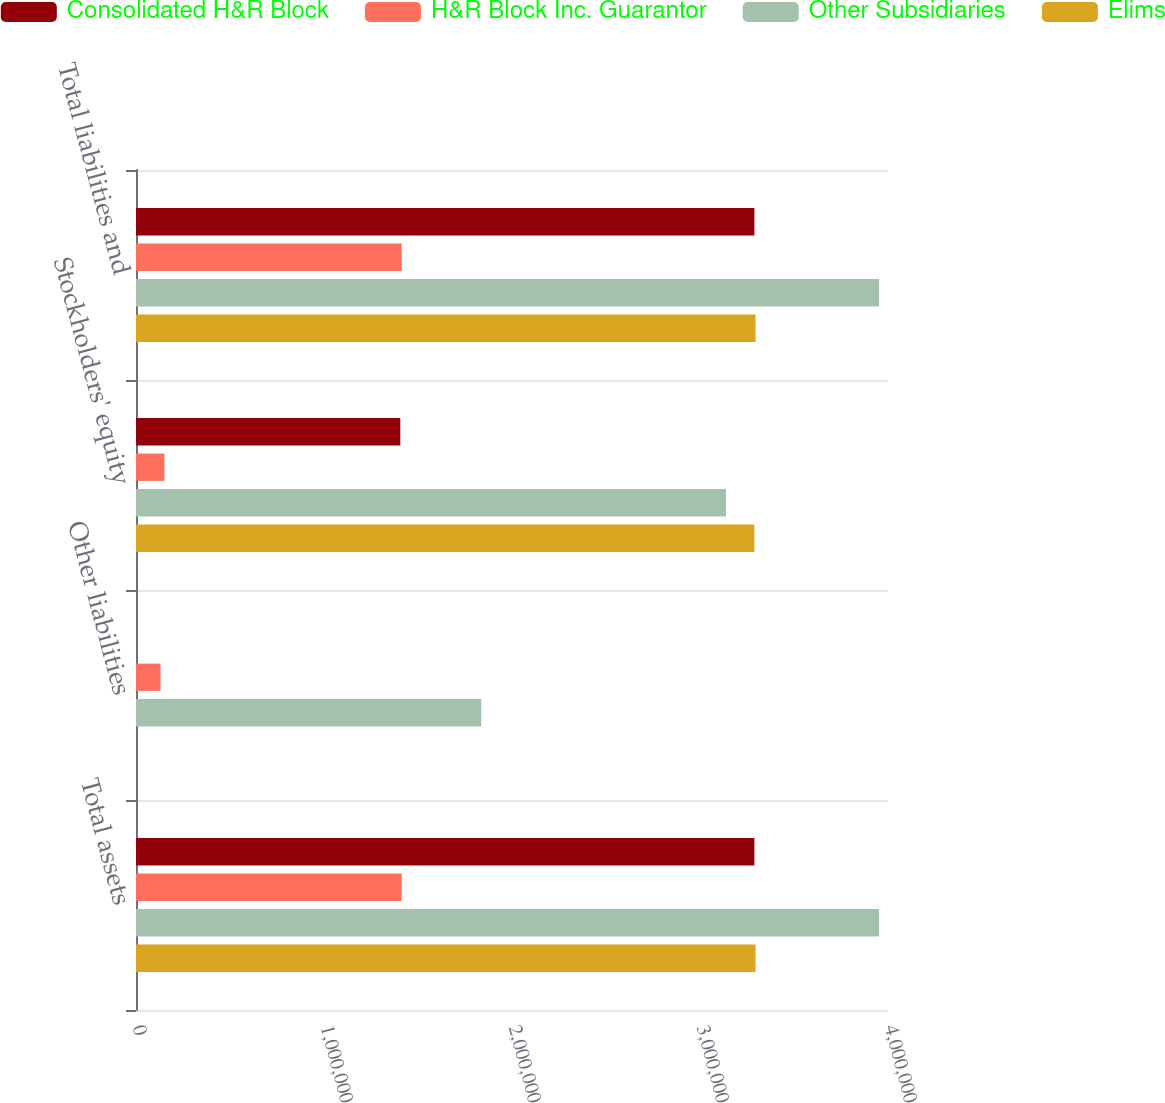Convert chart to OTSL. <chart><loc_0><loc_0><loc_500><loc_500><stacked_bar_chart><ecel><fcel>Total assets<fcel>Other liabilities<fcel>Stockholders' equity<fcel>Total liabilities and<nl><fcel>Consolidated H&R Block<fcel>3.28947e+06<fcel>2<fcel>1.40586e+06<fcel>3.28947e+06<nl><fcel>H&R Block Inc. Guarantor<fcel>1.41348e+06<fcel>130362<fcel>151211<fcel>1.41348e+06<nl><fcel>Other Subsidiaries<fcel>3.95243e+06<fcel>1.83648e+06<fcel>3.13822e+06<fcel>3.95243e+06<nl><fcel>Elims<fcel>3.29566e+06<fcel>12<fcel>3.28944e+06<fcel>3.29566e+06<nl></chart> 